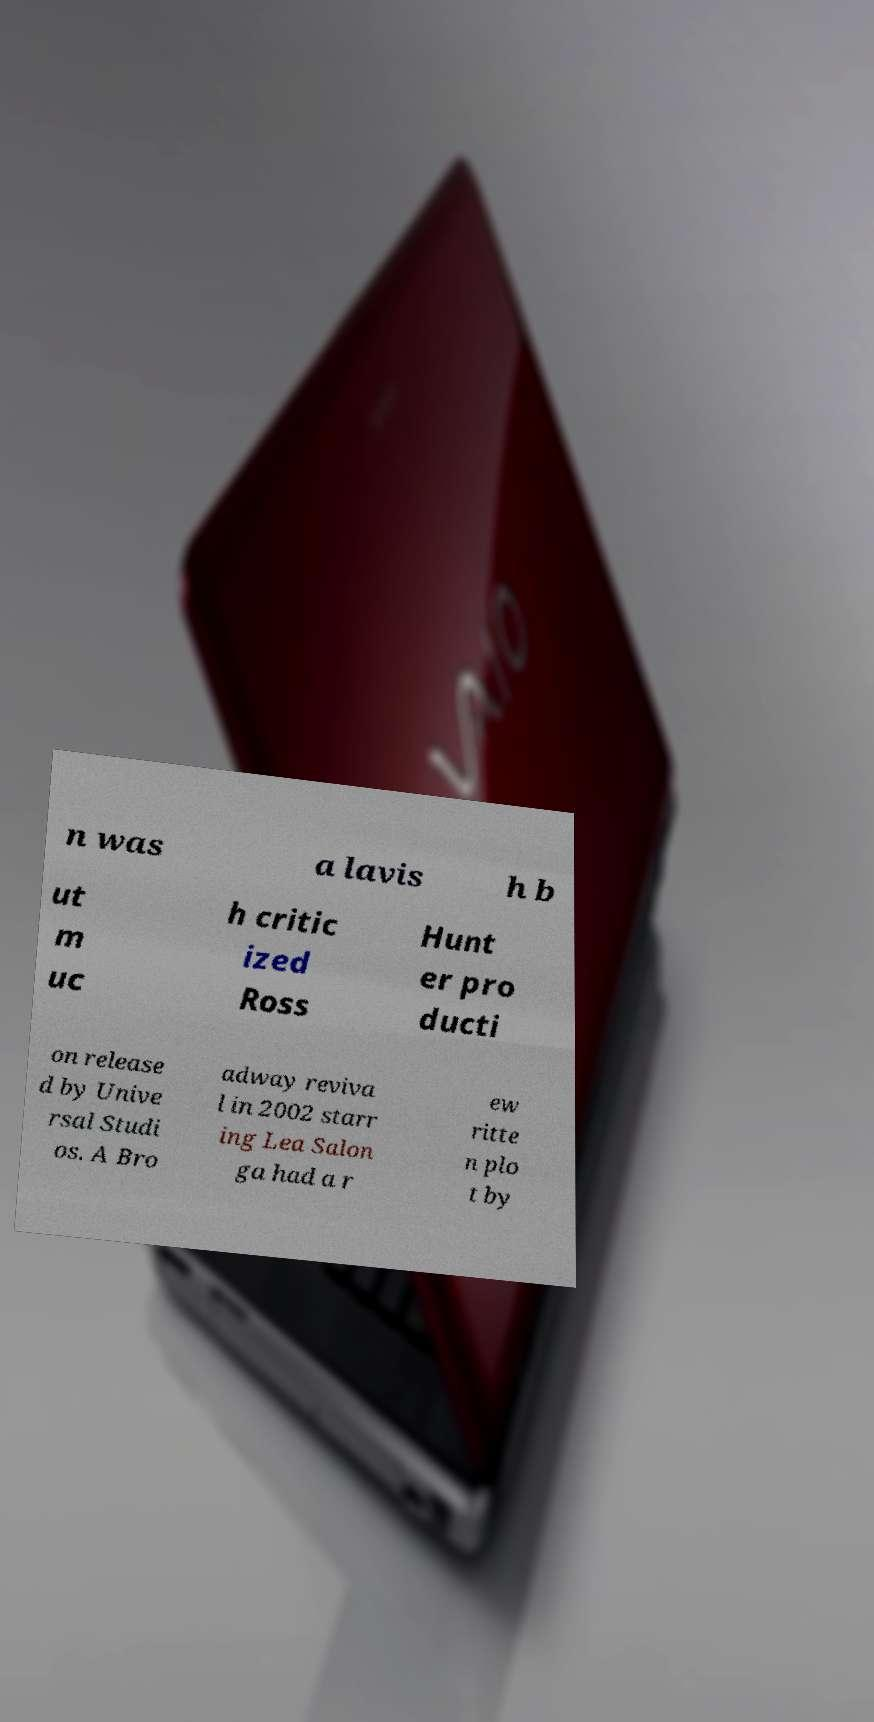I need the written content from this picture converted into text. Can you do that? n was a lavis h b ut m uc h critic ized Ross Hunt er pro ducti on release d by Unive rsal Studi os. A Bro adway reviva l in 2002 starr ing Lea Salon ga had a r ew ritte n plo t by 